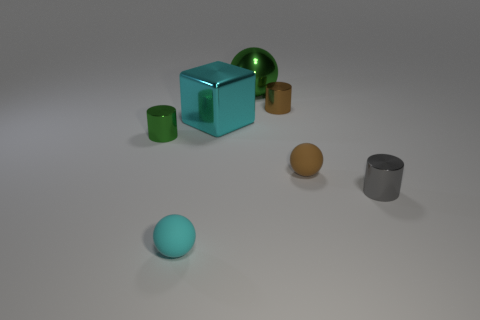Is the big ball the same color as the block?
Keep it short and to the point. No. What number of other objects are there of the same color as the big shiny ball?
Your response must be concise. 1. There is a shiny object that is both on the left side of the big green shiny sphere and to the right of the cyan ball; what shape is it?
Offer a very short reply. Cube. There is a green thing that is to the right of the thing in front of the tiny gray cylinder; is there a thing behind it?
Provide a succinct answer. No. How many other objects are there of the same material as the brown cylinder?
Make the answer very short. 4. What number of tiny gray objects are there?
Make the answer very short. 1. What number of things are either small gray metal things or tiny things right of the green metallic cylinder?
Keep it short and to the point. 4. Are there any other things that are the same shape as the brown shiny thing?
Give a very brief answer. Yes. There is a matte sphere that is in front of the gray metal cylinder; does it have the same size as the tiny green object?
Your answer should be very brief. Yes. How many matte objects are small gray cylinders or big spheres?
Give a very brief answer. 0. 